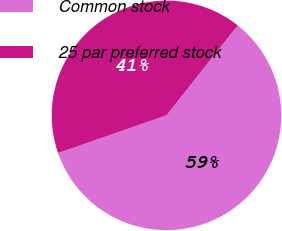<chart> <loc_0><loc_0><loc_500><loc_500><pie_chart><fcel>Common stock<fcel>25 par preferred stock<nl><fcel>59.02%<fcel>40.98%<nl></chart> 